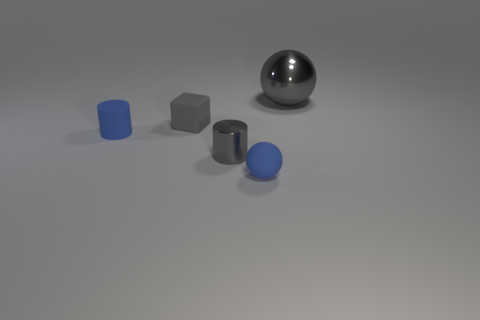There is a large thing that is the same material as the gray cylinder; what is its color?
Keep it short and to the point. Gray. Are there fewer big green cylinders than large gray balls?
Your response must be concise. Yes. There is a tiny gray thing in front of the tiny gray rubber cube; is it the same shape as the metallic thing that is right of the small blue ball?
Your answer should be very brief. No. How many objects are either small metallic cylinders or small cyan objects?
Provide a short and direct response. 1. There is a shiny cylinder that is the same size as the blue matte cylinder; what color is it?
Provide a succinct answer. Gray. There is a tiny matte thing behind the tiny blue matte cylinder; how many gray spheres are in front of it?
Your response must be concise. 0. What number of tiny blue objects are both in front of the small metal thing and to the left of the gray rubber object?
Provide a short and direct response. 0. How many objects are either objects that are behind the small blue ball or tiny matte objects that are on the right side of the tiny matte cylinder?
Provide a succinct answer. 5. How many other things are the same size as the blue ball?
Your answer should be compact. 3. There is a shiny object in front of the sphere that is behind the tiny matte sphere; what is its shape?
Your answer should be very brief. Cylinder. 